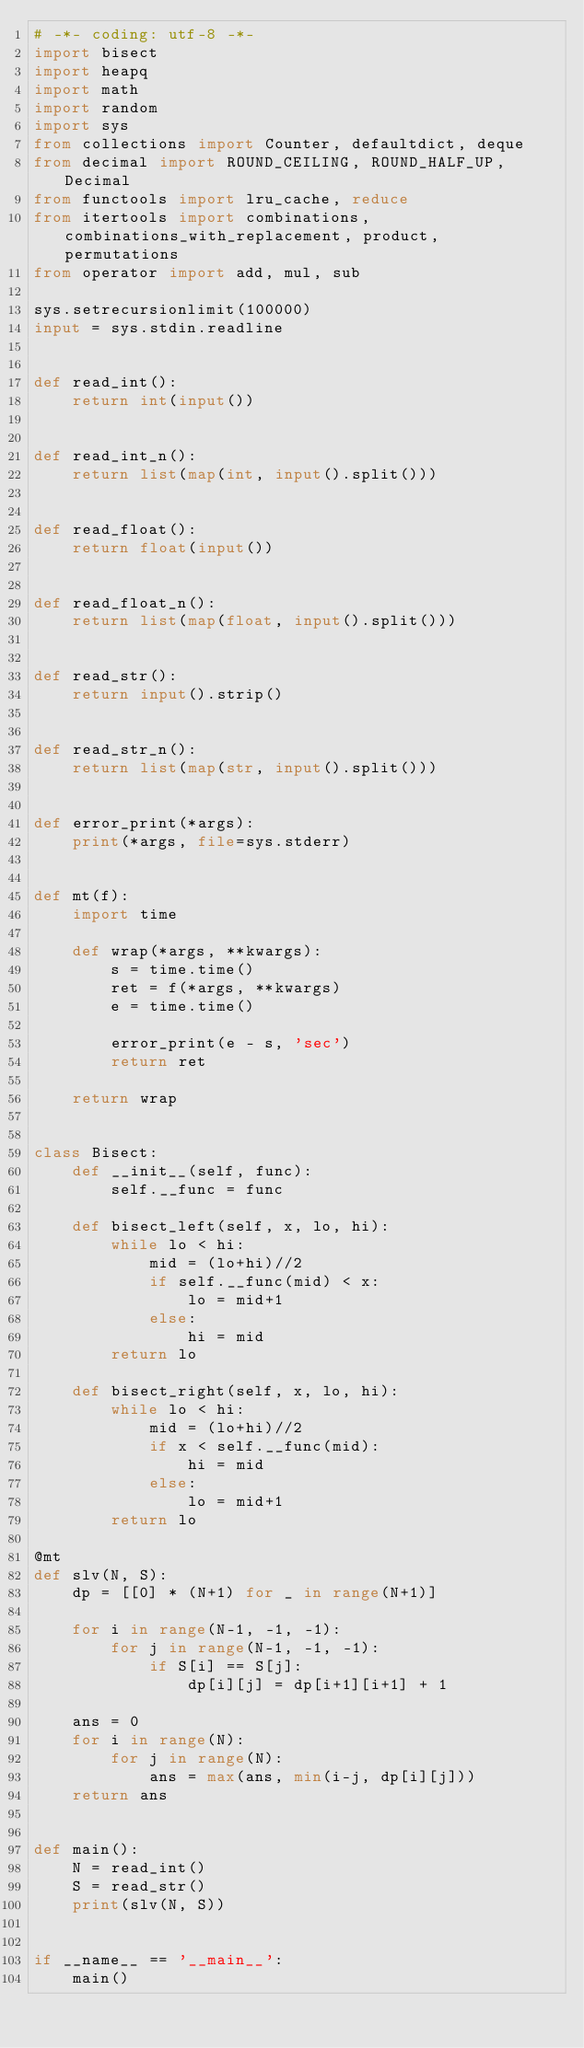Convert code to text. <code><loc_0><loc_0><loc_500><loc_500><_Python_># -*- coding: utf-8 -*-
import bisect
import heapq
import math
import random
import sys
from collections import Counter, defaultdict, deque
from decimal import ROUND_CEILING, ROUND_HALF_UP, Decimal
from functools import lru_cache, reduce
from itertools import combinations, combinations_with_replacement, product, permutations
from operator import add, mul, sub

sys.setrecursionlimit(100000)
input = sys.stdin.readline


def read_int():
    return int(input())


def read_int_n():
    return list(map(int, input().split()))


def read_float():
    return float(input())


def read_float_n():
    return list(map(float, input().split()))


def read_str():
    return input().strip()


def read_str_n():
    return list(map(str, input().split()))


def error_print(*args):
    print(*args, file=sys.stderr)


def mt(f):
    import time

    def wrap(*args, **kwargs):
        s = time.time()
        ret = f(*args, **kwargs)
        e = time.time()

        error_print(e - s, 'sec')
        return ret

    return wrap


class Bisect:
    def __init__(self, func):
        self.__func = func

    def bisect_left(self, x, lo, hi):
        while lo < hi:
            mid = (lo+hi)//2
            if self.__func(mid) < x:
                lo = mid+1
            else:
                hi = mid
        return lo

    def bisect_right(self, x, lo, hi):
        while lo < hi:
            mid = (lo+hi)//2
            if x < self.__func(mid):
                hi = mid
            else:
                lo = mid+1
        return lo

@mt
def slv(N, S):
    dp = [[0] * (N+1) for _ in range(N+1)]

    for i in range(N-1, -1, -1):
        for j in range(N-1, -1, -1):
            if S[i] == S[j]:
                dp[i][j] = dp[i+1][i+1] + 1
    
    ans = 0
    for i in range(N):
        for j in range(N):
            ans = max(ans, min(i-j, dp[i][j]))
    return ans


def main():
    N = read_int()
    S = read_str()
    print(slv(N, S))


if __name__ == '__main__':
    main()
</code> 